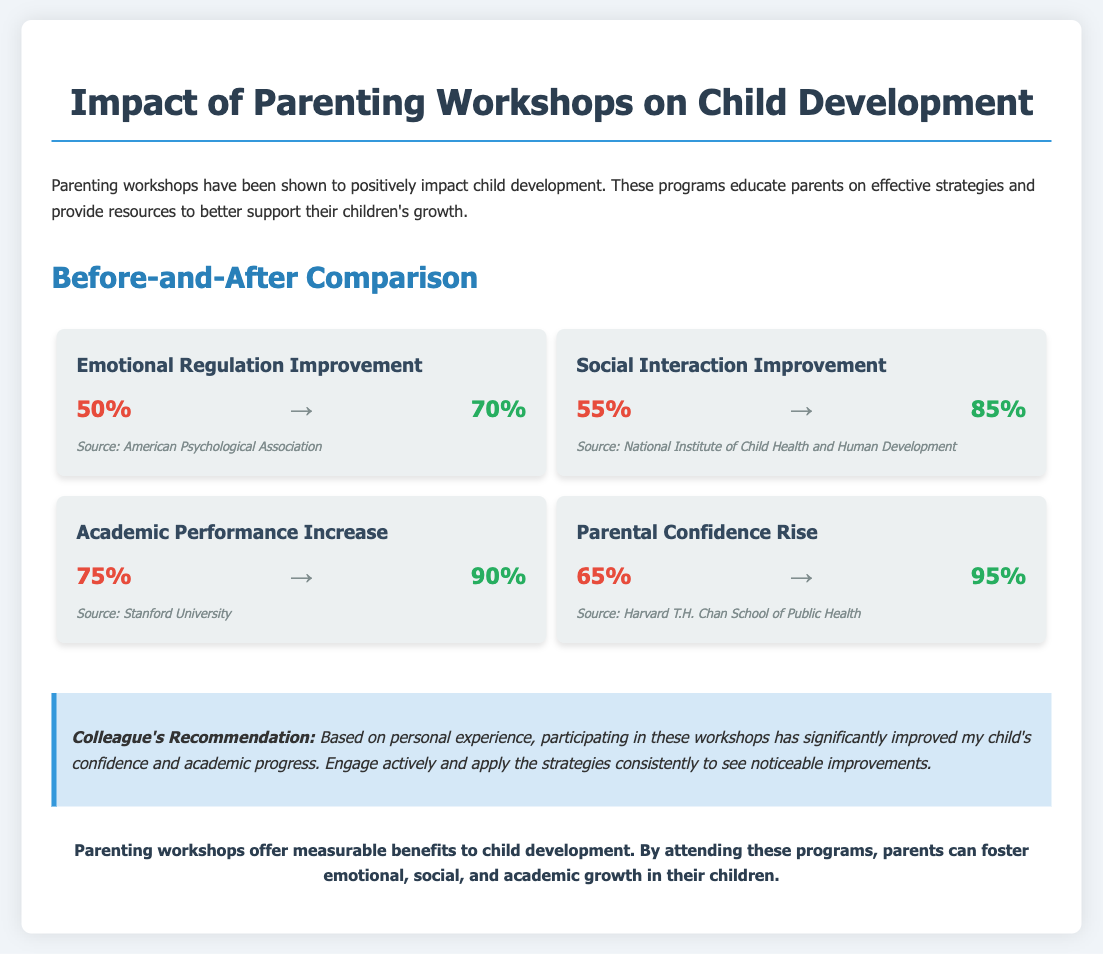What percentage showed improvement in emotional regulation before the workshops? The document states that emotional regulation improved from 50% before the workshops.
Answer: 50% What is the percentage increase in social interaction after attending the workshops? The document indicates that social interaction improved to 85% after the workshops.
Answer: 85% What was the rise in parental confidence percentage after the workshops? According to the document, parental confidence rose from 65% to 95%.
Answer: 30% Which organization provided the source for academic performance improvement? The document lists Stanford University as the source for academic performance improvement statistics.
Answer: Stanford University What is the main conclusion drawn in the infographic? The conclusion emphasizes that parenting workshops foster emotional, social, and academic growth in children.
Answer: Parenting workshops offer measurable benefits to child development What improvement did the workshops achieve in academic performance? The document shows that academic performance increased from 75% to 90% after the workshops.
Answer: 15% What color signifies the "before" statistics in the infographic? The "before" statistics are represented in red color in the document.
Answer: Red What color signifies the "after" statistics in the infographic? The "after" statistics are represented in green color in the document.
Answer: Green 